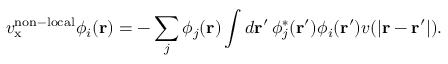<formula> <loc_0><loc_0><loc_500><loc_500>v _ { x } ^ { n o n - l o c a l } \phi _ { i } ( r ) = - \sum _ { j } \phi _ { j } ( r ) \int d r ^ { \prime } \, \phi _ { j } ^ { * } ( r ^ { \prime } ) \phi _ { i } ( r ^ { \prime } ) v ( | r - r ^ { \prime } | ) .</formula> 